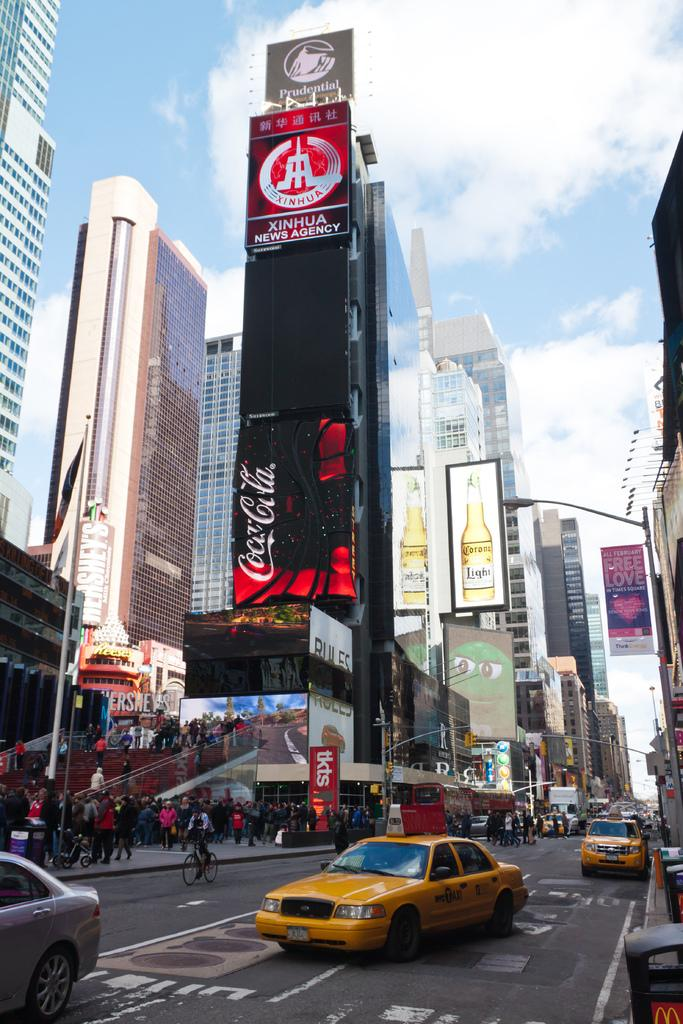Provide a one-sentence caption for the provided image. A TALL BUILDING WITH A COCA COLA BILLBOARD ON THE SIDE OF IT. 